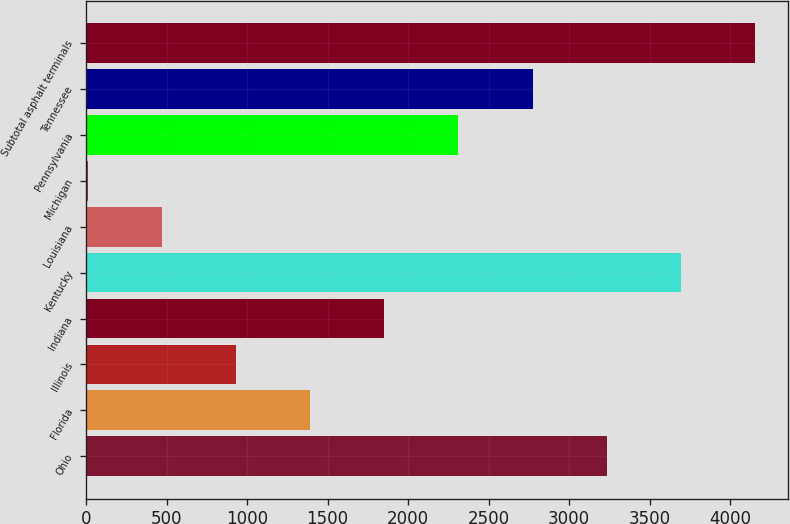Convert chart to OTSL. <chart><loc_0><loc_0><loc_500><loc_500><bar_chart><fcel>Ohio<fcel>Florida<fcel>Illinois<fcel>Indiana<fcel>Kentucky<fcel>Louisiana<fcel>Michigan<fcel>Pennsylvania<fcel>Tennessee<fcel>Subtotal asphalt terminals<nl><fcel>3233.4<fcel>1392.6<fcel>932.4<fcel>1852.8<fcel>3693.6<fcel>472.2<fcel>12<fcel>2313<fcel>2773.2<fcel>4153.8<nl></chart> 